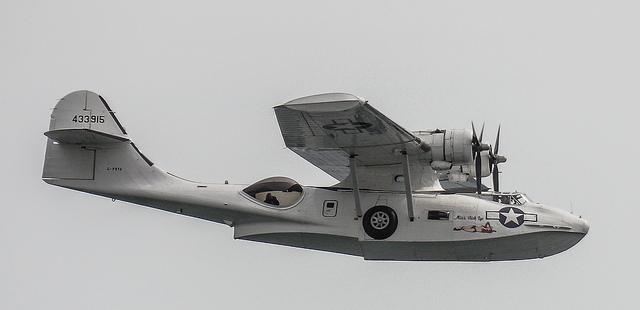What type of plane is this?
Concise answer only. Bomber. What number is on the tail?
Be succinct. 433915. What color is the plain?
Give a very brief answer. White. 